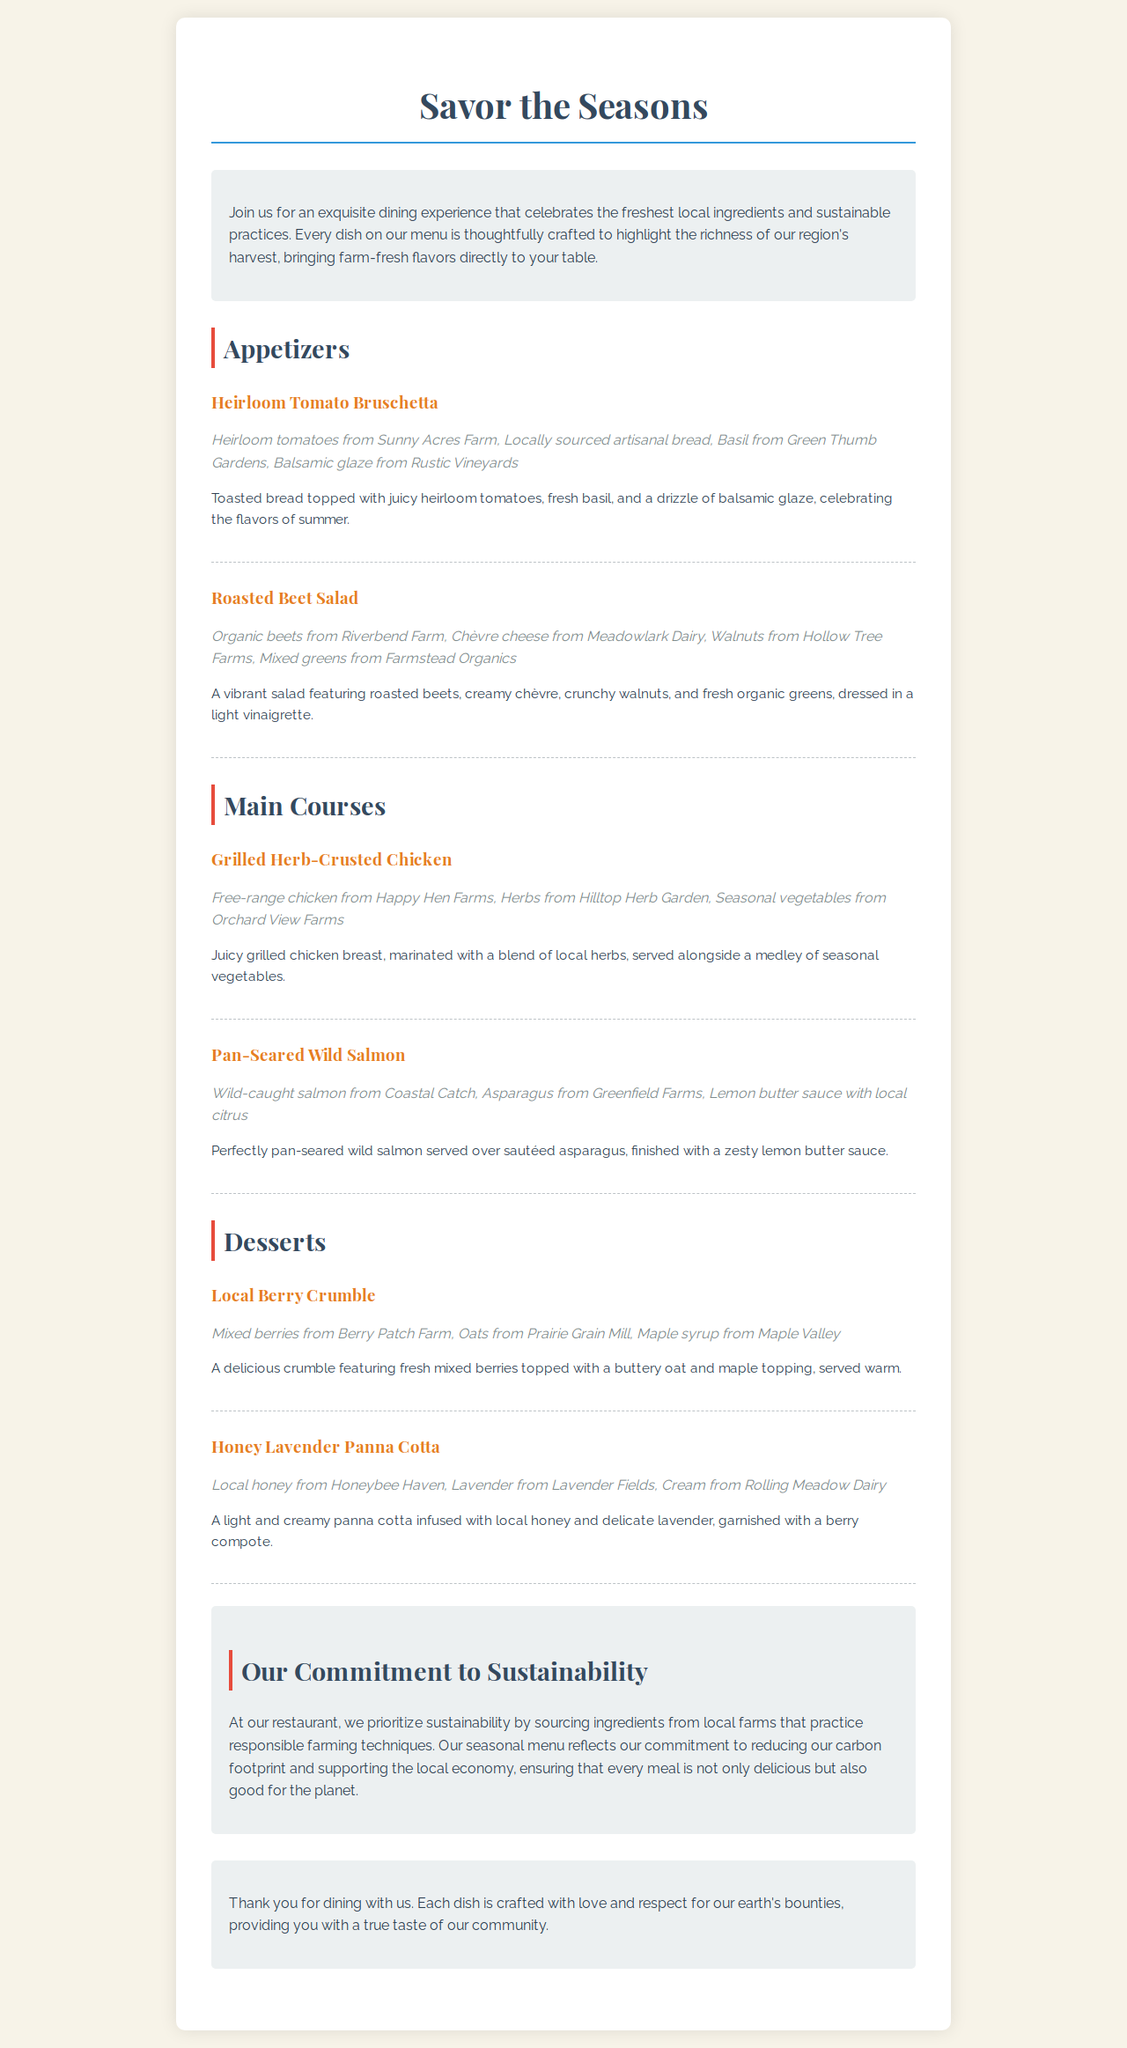What is the title of the menu? The title of the menu is presented at the top of the document, which is styled prominently.
Answer: Savor the Seasons Which farm provides the heirloom tomatoes? The heirloom tomatoes are sourced from a specific farm mentioned in the appetizer section.
Answer: Sunny Acres Farm What type of cheese is used in the Roasted Beet Salad? The type of cheese is listed in the ingredients of the salad, which indicates its origin.
Answer: Chèvre cheese How is the chicken in the Grilled Herb-Crusted Chicken prepared? The cooking method for the chicken is described in the menu item details.
Answer: Grilled What dessert features local honey? The dessert name is specifically mentioned alongside its key ingredient.
Answer: Honey Lavender Panna Cotta What is the primary commitment highlighted in the sustainability section? The main focus of the sustainability section is directly stated in a single phrase.
Answer: Sourcing ingredients Which ingredient is used to top the Local Berry Crumble? The topping ingredient is detailed in the description of the dessert.
Answer: Buttery oat and maple topping How many appetizers are listed in the menu? The total number of appetizers is determined by counting the sections provided in the document.
Answer: Two 